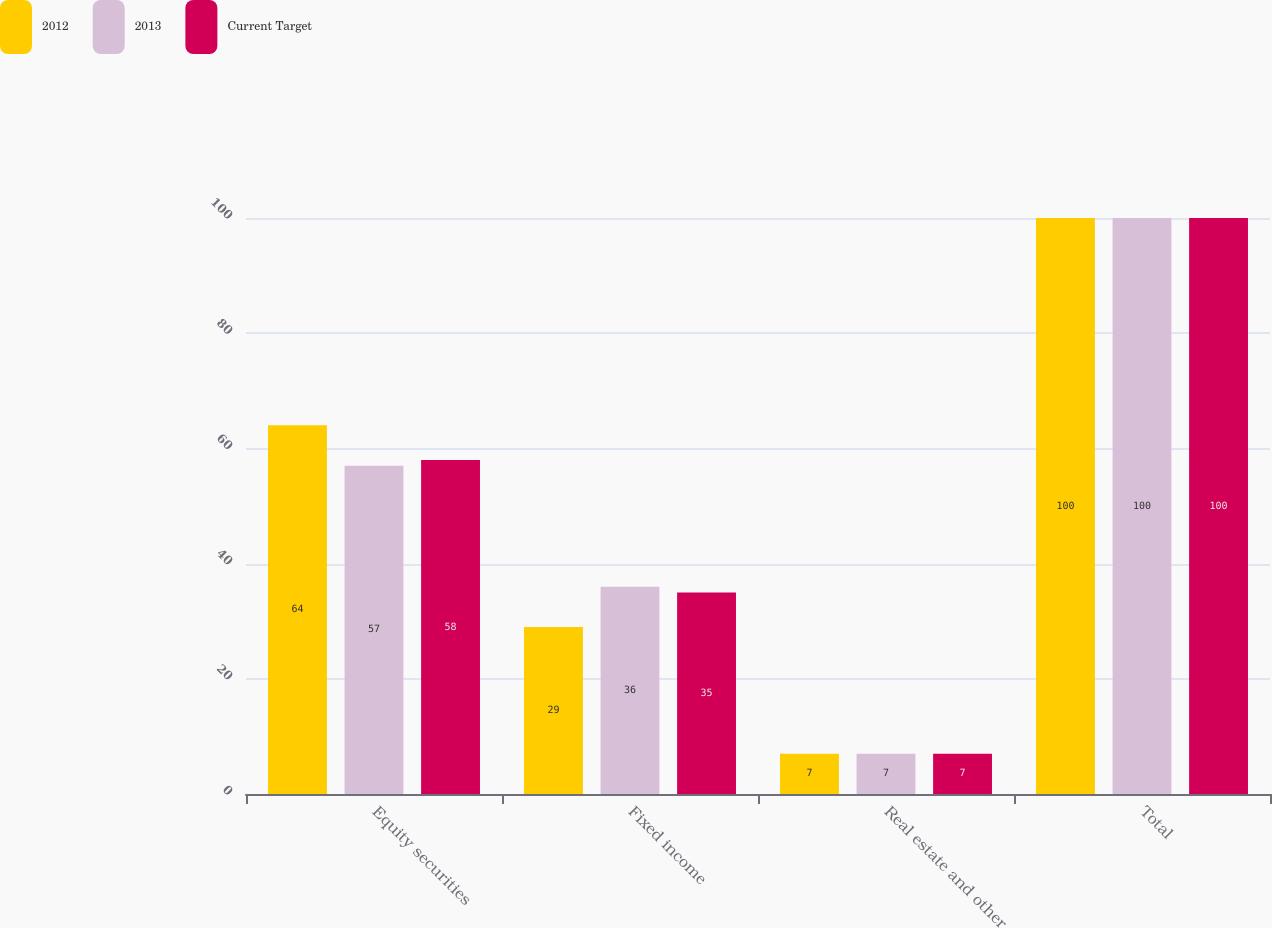Convert chart to OTSL. <chart><loc_0><loc_0><loc_500><loc_500><stacked_bar_chart><ecel><fcel>Equity securities<fcel>Fixed income<fcel>Real estate and other<fcel>Total<nl><fcel>2012<fcel>64<fcel>29<fcel>7<fcel>100<nl><fcel>2013<fcel>57<fcel>36<fcel>7<fcel>100<nl><fcel>Current Target<fcel>58<fcel>35<fcel>7<fcel>100<nl></chart> 